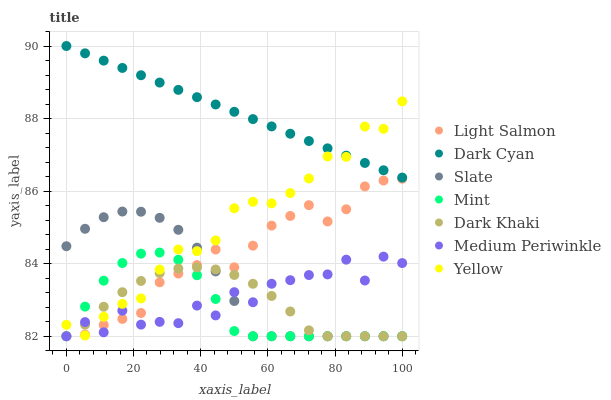Does Mint have the minimum area under the curve?
Answer yes or no. Yes. Does Dark Cyan have the maximum area under the curve?
Answer yes or no. Yes. Does Slate have the minimum area under the curve?
Answer yes or no. No. Does Slate have the maximum area under the curve?
Answer yes or no. No. Is Dark Cyan the smoothest?
Answer yes or no. Yes. Is Medium Periwinkle the roughest?
Answer yes or no. Yes. Is Slate the smoothest?
Answer yes or no. No. Is Slate the roughest?
Answer yes or no. No. Does Light Salmon have the lowest value?
Answer yes or no. Yes. Does Yellow have the lowest value?
Answer yes or no. No. Does Dark Cyan have the highest value?
Answer yes or no. Yes. Does Slate have the highest value?
Answer yes or no. No. Is Dark Khaki less than Dark Cyan?
Answer yes or no. Yes. Is Dark Cyan greater than Mint?
Answer yes or no. Yes. Does Mint intersect Slate?
Answer yes or no. Yes. Is Mint less than Slate?
Answer yes or no. No. Is Mint greater than Slate?
Answer yes or no. No. Does Dark Khaki intersect Dark Cyan?
Answer yes or no. No. 